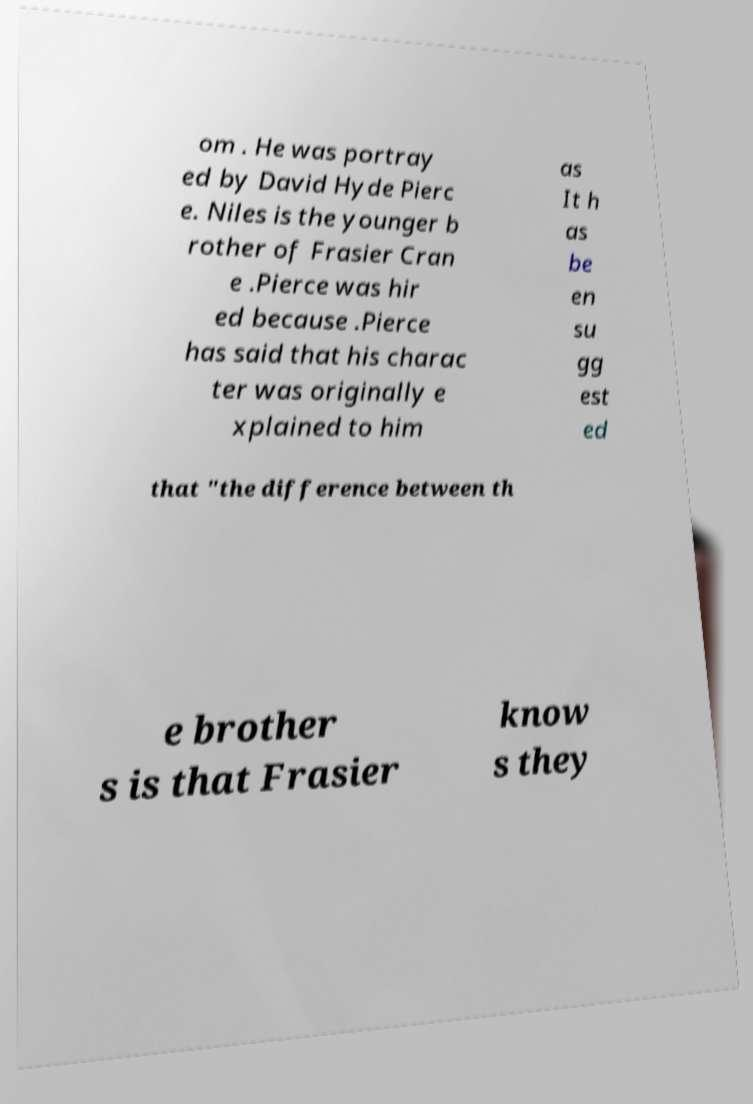Can you accurately transcribe the text from the provided image for me? om . He was portray ed by David Hyde Pierc e. Niles is the younger b rother of Frasier Cran e .Pierce was hir ed because .Pierce has said that his charac ter was originally e xplained to him as It h as be en su gg est ed that "the difference between th e brother s is that Frasier know s they 